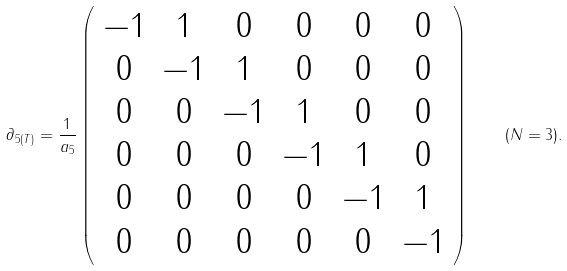Convert formula to latex. <formula><loc_0><loc_0><loc_500><loc_500>\partial _ { 5 ( T ) } = \frac { 1 } { a _ { 5 } } \left ( \begin{array} { c c c c c c } - 1 & 1 & 0 & 0 & 0 & 0 \\ 0 & - 1 & 1 & 0 & 0 & 0 \\ 0 & 0 & - 1 & 1 & 0 & 0 \\ 0 & 0 & 0 & - 1 & 1 & 0 \\ 0 & 0 & 0 & 0 & - 1 & 1 \\ 0 & 0 & 0 & 0 & 0 & - 1 \end{array} \right ) \quad ( N = 3 ) .</formula> 